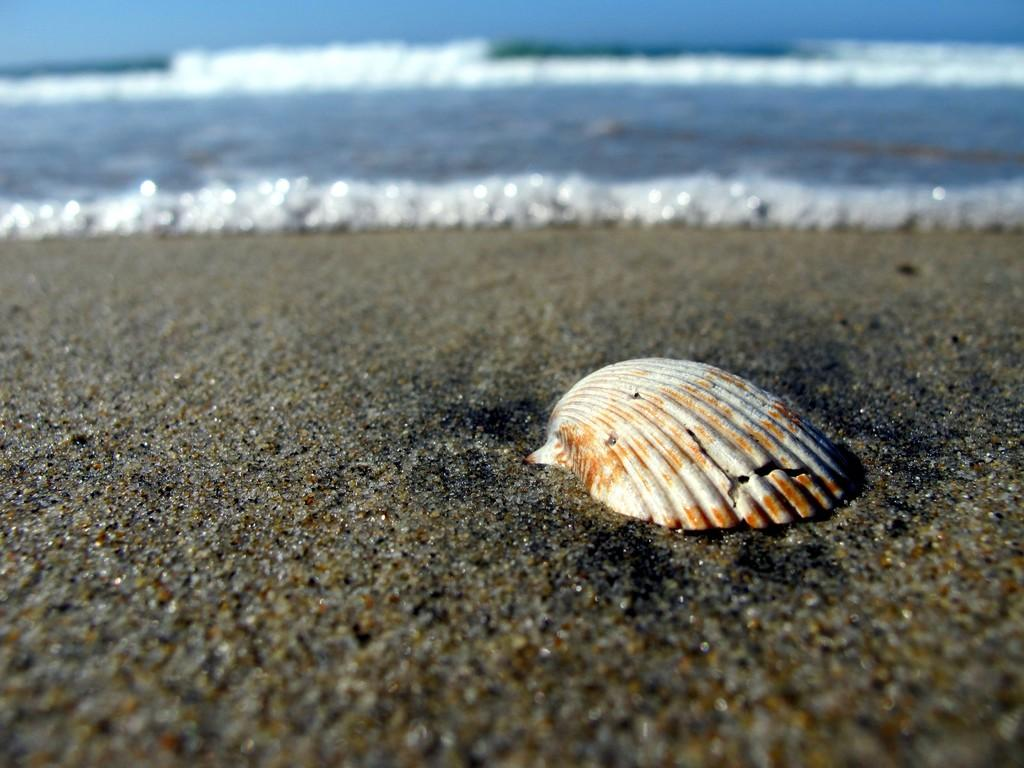What is the main object on the sand in the image? There is an object on the sand in the image, but the specific object is not mentioned in the facts. What can be seen in the background of the image? There is water visible in the background of the image. What type of insect can be seen crawling on the object in the image? There is no insect present in the image. What is the scent of the object in the image? The scent of the object cannot be determined from the image. 